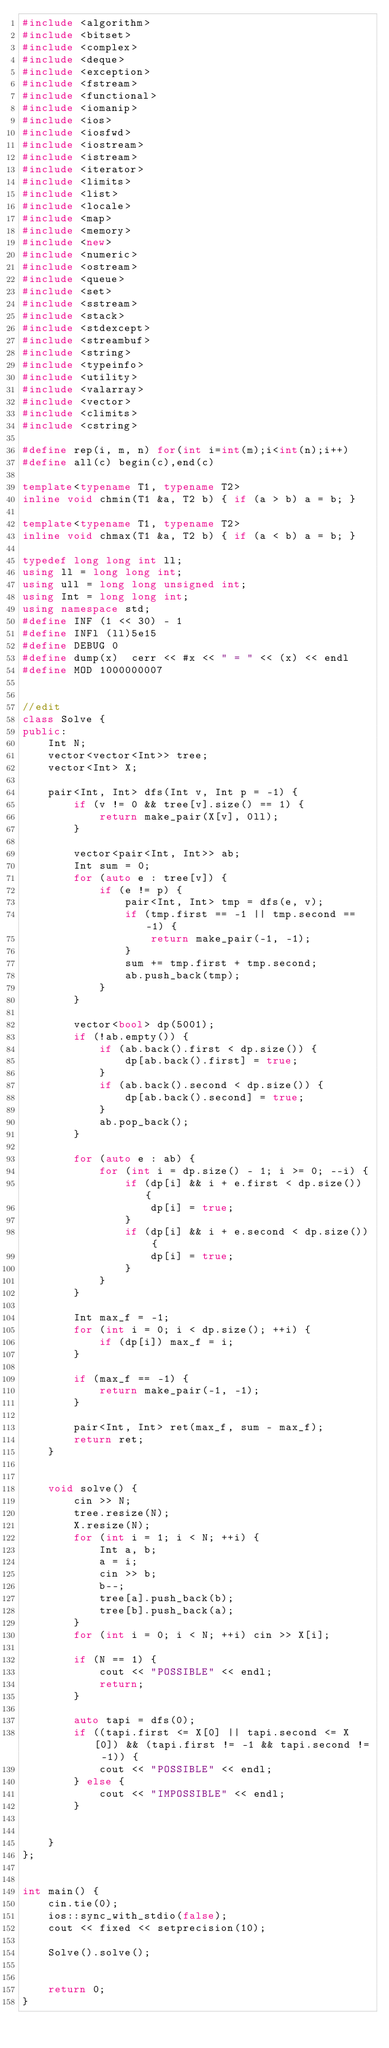<code> <loc_0><loc_0><loc_500><loc_500><_C++_>#include <algorithm>
#include <bitset>
#include <complex>
#include <deque>
#include <exception>
#include <fstream>
#include <functional>
#include <iomanip>
#include <ios>
#include <iosfwd>
#include <iostream>
#include <istream>
#include <iterator>
#include <limits>
#include <list>
#include <locale>
#include <map>
#include <memory>
#include <new>
#include <numeric>
#include <ostream>
#include <queue>
#include <set>
#include <sstream>
#include <stack>
#include <stdexcept>
#include <streambuf>
#include <string>
#include <typeinfo>
#include <utility>
#include <valarray>
#include <vector>
#include <climits>
#include <cstring>

#define rep(i, m, n) for(int i=int(m);i<int(n);i++)
#define all(c) begin(c),end(c)

template<typename T1, typename T2>
inline void chmin(T1 &a, T2 b) { if (a > b) a = b; }

template<typename T1, typename T2>
inline void chmax(T1 &a, T2 b) { if (a < b) a = b; }

typedef long long int ll;
using ll = long long int;
using ull = long long unsigned int;
using Int = long long int;
using namespace std;
#define INF (1 << 30) - 1
#define INFl (ll)5e15
#define DEBUG 0
#define dump(x)  cerr << #x << " = " << (x) << endl
#define MOD 1000000007


//edit
class Solve {
public:
    Int N;
    vector<vector<Int>> tree;
    vector<Int> X;

    pair<Int, Int> dfs(Int v, Int p = -1) {
        if (v != 0 && tree[v].size() == 1) {
            return make_pair(X[v], 0ll);
        }

        vector<pair<Int, Int>> ab;
        Int sum = 0;
        for (auto e : tree[v]) {
            if (e != p) {
                pair<Int, Int> tmp = dfs(e, v);
                if (tmp.first == -1 || tmp.second == -1) {
                    return make_pair(-1, -1);
                }
                sum += tmp.first + tmp.second;
                ab.push_back(tmp);
            }
        }

        vector<bool> dp(5001);
        if (!ab.empty()) {
            if (ab.back().first < dp.size()) {
                dp[ab.back().first] = true;
            }
            if (ab.back().second < dp.size()) {
                dp[ab.back().second] = true;
            }
            ab.pop_back();
        }

        for (auto e : ab) {
            for (int i = dp.size() - 1; i >= 0; --i) {
                if (dp[i] && i + e.first < dp.size()) {
                    dp[i] = true;
                }
                if (dp[i] && i + e.second < dp.size()) {
                    dp[i] = true;
                }
            }
        }

        Int max_f = -1;
        for (int i = 0; i < dp.size(); ++i) {
            if (dp[i]) max_f = i;
        }

        if (max_f == -1) {
            return make_pair(-1, -1);
        }

        pair<Int, Int> ret(max_f, sum - max_f);
        return ret;
    }


    void solve() {
        cin >> N;
        tree.resize(N);
        X.resize(N);
        for (int i = 1; i < N; ++i) {
            Int a, b;
            a = i;
            cin >> b;
            b--;
            tree[a].push_back(b);
            tree[b].push_back(a);
        }
        for (int i = 0; i < N; ++i) cin >> X[i];

        if (N == 1) {
            cout << "POSSIBLE" << endl;
            return;
        }

        auto tapi = dfs(0);
        if ((tapi.first <= X[0] || tapi.second <= X[0]) && (tapi.first != -1 && tapi.second != -1)) {
            cout << "POSSIBLE" << endl;
        } else {
            cout << "IMPOSSIBLE" << endl;
        }


    }
};


int main() {
    cin.tie(0);
    ios::sync_with_stdio(false);
    cout << fixed << setprecision(10);

    Solve().solve();


    return 0;
}
</code> 